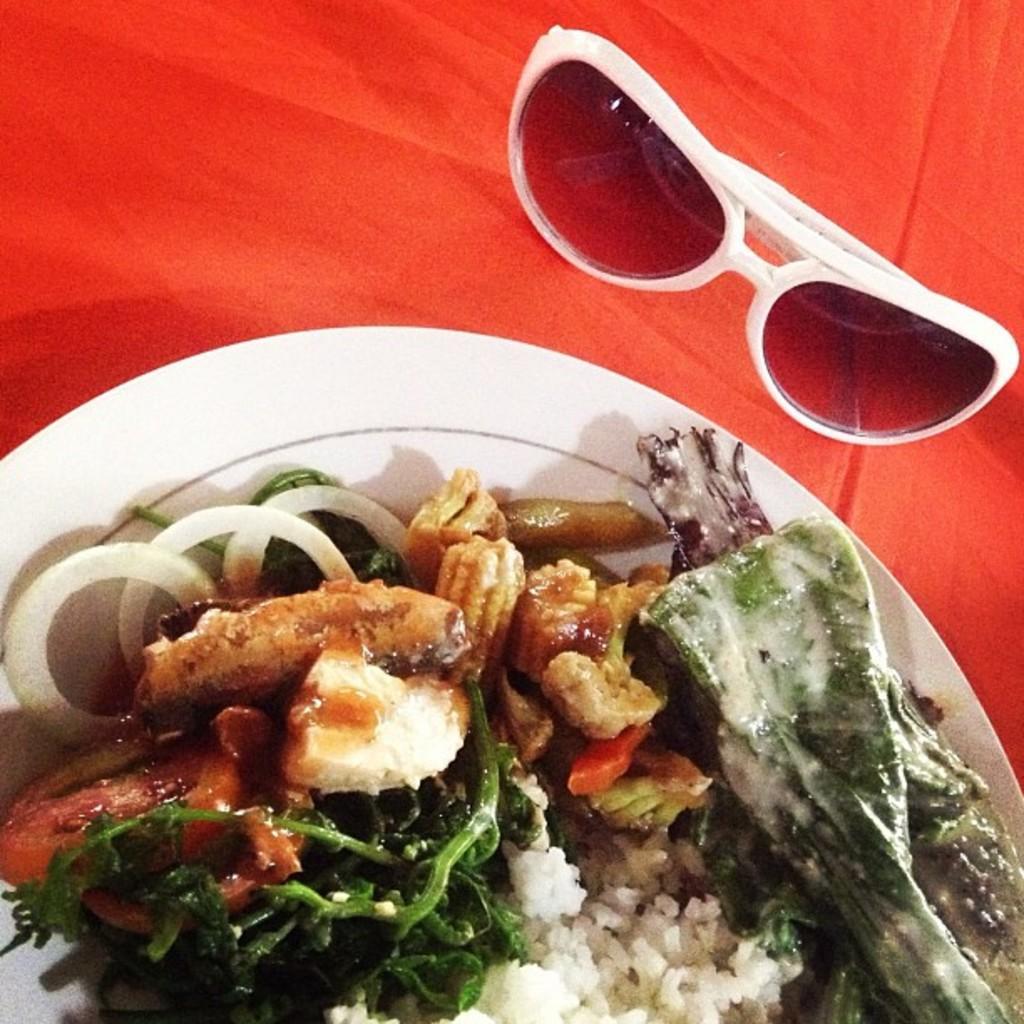How would you summarize this image in a sentence or two? In the picture we can see a plate with food items like some vegetable slices and beside the plate we can see a goggles are placed on the red color cloth. 